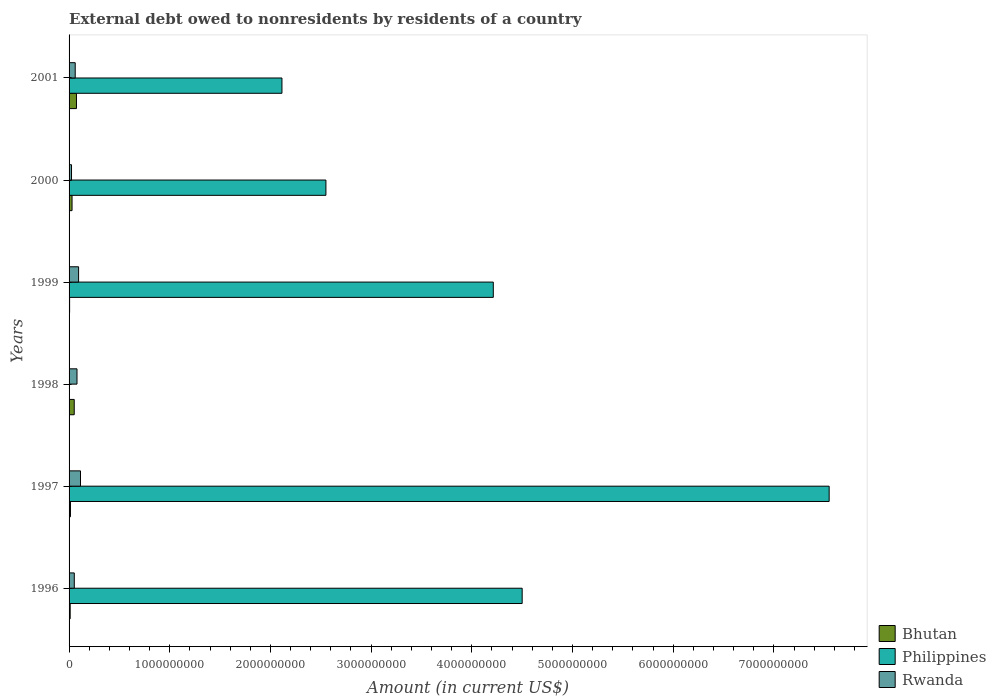How many different coloured bars are there?
Your answer should be very brief. 3. How many groups of bars are there?
Your answer should be very brief. 6. Are the number of bars per tick equal to the number of legend labels?
Your answer should be compact. No. Are the number of bars on each tick of the Y-axis equal?
Offer a very short reply. No. How many bars are there on the 1st tick from the bottom?
Provide a short and direct response. 3. What is the label of the 5th group of bars from the top?
Make the answer very short. 1997. In how many cases, is the number of bars for a given year not equal to the number of legend labels?
Keep it short and to the point. 1. What is the external debt owed by residents in Rwanda in 1999?
Your answer should be compact. 9.46e+07. Across all years, what is the maximum external debt owed by residents in Philippines?
Keep it short and to the point. 7.55e+09. Across all years, what is the minimum external debt owed by residents in Rwanda?
Provide a short and direct response. 2.43e+07. In which year was the external debt owed by residents in Bhutan maximum?
Keep it short and to the point. 2001. What is the total external debt owed by residents in Philippines in the graph?
Provide a succinct answer. 2.09e+1. What is the difference between the external debt owed by residents in Philippines in 1996 and that in 2000?
Provide a succinct answer. 1.95e+09. What is the difference between the external debt owed by residents in Bhutan in 1998 and the external debt owed by residents in Rwanda in 1997?
Your answer should be compact. -6.22e+07. What is the average external debt owed by residents in Rwanda per year?
Provide a succinct answer. 7.07e+07. In the year 2001, what is the difference between the external debt owed by residents in Bhutan and external debt owed by residents in Rwanda?
Give a very brief answer. 1.24e+07. In how many years, is the external debt owed by residents in Bhutan greater than 2200000000 US$?
Offer a terse response. 0. What is the ratio of the external debt owed by residents in Rwanda in 1997 to that in 1999?
Your answer should be very brief. 1.2. What is the difference between the highest and the second highest external debt owed by residents in Philippines?
Make the answer very short. 3.05e+09. What is the difference between the highest and the lowest external debt owed by residents in Rwanda?
Ensure brevity in your answer.  8.92e+07. In how many years, is the external debt owed by residents in Philippines greater than the average external debt owed by residents in Philippines taken over all years?
Keep it short and to the point. 3. Is the sum of the external debt owed by residents in Rwanda in 1997 and 1998 greater than the maximum external debt owed by residents in Philippines across all years?
Offer a terse response. No. Is it the case that in every year, the sum of the external debt owed by residents in Philippines and external debt owed by residents in Rwanda is greater than the external debt owed by residents in Bhutan?
Make the answer very short. Yes. Are all the bars in the graph horizontal?
Your response must be concise. Yes. Are the values on the major ticks of X-axis written in scientific E-notation?
Your answer should be very brief. No. Does the graph contain grids?
Your answer should be compact. No. How many legend labels are there?
Your answer should be compact. 3. How are the legend labels stacked?
Ensure brevity in your answer.  Vertical. What is the title of the graph?
Offer a very short reply. External debt owed to nonresidents by residents of a country. What is the label or title of the X-axis?
Give a very brief answer. Amount (in current US$). What is the Amount (in current US$) in Bhutan in 1996?
Offer a very short reply. 1.10e+07. What is the Amount (in current US$) of Philippines in 1996?
Offer a very short reply. 4.50e+09. What is the Amount (in current US$) in Rwanda in 1996?
Make the answer very short. 5.19e+07. What is the Amount (in current US$) in Bhutan in 1997?
Provide a succinct answer. 1.38e+07. What is the Amount (in current US$) of Philippines in 1997?
Keep it short and to the point. 7.55e+09. What is the Amount (in current US$) in Rwanda in 1997?
Your response must be concise. 1.13e+08. What is the Amount (in current US$) in Bhutan in 1998?
Your answer should be very brief. 5.13e+07. What is the Amount (in current US$) in Philippines in 1998?
Your response must be concise. 0. What is the Amount (in current US$) in Rwanda in 1998?
Provide a succinct answer. 7.87e+07. What is the Amount (in current US$) in Bhutan in 1999?
Make the answer very short. 5.40e+06. What is the Amount (in current US$) of Philippines in 1999?
Offer a terse response. 4.21e+09. What is the Amount (in current US$) in Rwanda in 1999?
Keep it short and to the point. 9.46e+07. What is the Amount (in current US$) in Bhutan in 2000?
Give a very brief answer. 2.96e+07. What is the Amount (in current US$) in Philippines in 2000?
Make the answer very short. 2.55e+09. What is the Amount (in current US$) in Rwanda in 2000?
Keep it short and to the point. 2.43e+07. What is the Amount (in current US$) of Bhutan in 2001?
Your answer should be compact. 7.34e+07. What is the Amount (in current US$) of Philippines in 2001?
Give a very brief answer. 2.11e+09. What is the Amount (in current US$) in Rwanda in 2001?
Make the answer very short. 6.10e+07. Across all years, what is the maximum Amount (in current US$) of Bhutan?
Provide a succinct answer. 7.34e+07. Across all years, what is the maximum Amount (in current US$) of Philippines?
Your response must be concise. 7.55e+09. Across all years, what is the maximum Amount (in current US$) in Rwanda?
Your response must be concise. 1.13e+08. Across all years, what is the minimum Amount (in current US$) of Bhutan?
Ensure brevity in your answer.  5.40e+06. Across all years, what is the minimum Amount (in current US$) in Rwanda?
Make the answer very short. 2.43e+07. What is the total Amount (in current US$) of Bhutan in the graph?
Your answer should be compact. 1.84e+08. What is the total Amount (in current US$) in Philippines in the graph?
Provide a short and direct response. 2.09e+1. What is the total Amount (in current US$) in Rwanda in the graph?
Make the answer very short. 4.24e+08. What is the difference between the Amount (in current US$) in Bhutan in 1996 and that in 1997?
Your answer should be compact. -2.83e+06. What is the difference between the Amount (in current US$) in Philippines in 1996 and that in 1997?
Give a very brief answer. -3.05e+09. What is the difference between the Amount (in current US$) of Rwanda in 1996 and that in 1997?
Keep it short and to the point. -6.16e+07. What is the difference between the Amount (in current US$) of Bhutan in 1996 and that in 1998?
Your answer should be compact. -4.03e+07. What is the difference between the Amount (in current US$) of Rwanda in 1996 and that in 1998?
Ensure brevity in your answer.  -2.68e+07. What is the difference between the Amount (in current US$) of Bhutan in 1996 and that in 1999?
Provide a short and direct response. 5.57e+06. What is the difference between the Amount (in current US$) in Philippines in 1996 and that in 1999?
Your response must be concise. 2.87e+08. What is the difference between the Amount (in current US$) in Rwanda in 1996 and that in 1999?
Offer a terse response. -4.27e+07. What is the difference between the Amount (in current US$) of Bhutan in 1996 and that in 2000?
Your answer should be very brief. -1.86e+07. What is the difference between the Amount (in current US$) in Philippines in 1996 and that in 2000?
Offer a very short reply. 1.95e+09. What is the difference between the Amount (in current US$) in Rwanda in 1996 and that in 2000?
Ensure brevity in your answer.  2.76e+07. What is the difference between the Amount (in current US$) in Bhutan in 1996 and that in 2001?
Your answer should be very brief. -6.24e+07. What is the difference between the Amount (in current US$) in Philippines in 1996 and that in 2001?
Your answer should be very brief. 2.39e+09. What is the difference between the Amount (in current US$) in Rwanda in 1996 and that in 2001?
Ensure brevity in your answer.  -9.10e+06. What is the difference between the Amount (in current US$) in Bhutan in 1997 and that in 1998?
Provide a succinct answer. -3.75e+07. What is the difference between the Amount (in current US$) in Rwanda in 1997 and that in 1998?
Your answer should be very brief. 3.48e+07. What is the difference between the Amount (in current US$) of Bhutan in 1997 and that in 1999?
Keep it short and to the point. 8.40e+06. What is the difference between the Amount (in current US$) in Philippines in 1997 and that in 1999?
Give a very brief answer. 3.34e+09. What is the difference between the Amount (in current US$) in Rwanda in 1997 and that in 1999?
Ensure brevity in your answer.  1.89e+07. What is the difference between the Amount (in current US$) of Bhutan in 1997 and that in 2000?
Give a very brief answer. -1.58e+07. What is the difference between the Amount (in current US$) of Philippines in 1997 and that in 2000?
Your answer should be compact. 5.00e+09. What is the difference between the Amount (in current US$) of Rwanda in 1997 and that in 2000?
Your answer should be compact. 8.92e+07. What is the difference between the Amount (in current US$) in Bhutan in 1997 and that in 2001?
Your response must be concise. -5.96e+07. What is the difference between the Amount (in current US$) of Philippines in 1997 and that in 2001?
Provide a succinct answer. 5.43e+09. What is the difference between the Amount (in current US$) in Rwanda in 1997 and that in 2001?
Give a very brief answer. 5.25e+07. What is the difference between the Amount (in current US$) in Bhutan in 1998 and that in 1999?
Offer a terse response. 4.59e+07. What is the difference between the Amount (in current US$) in Rwanda in 1998 and that in 1999?
Your response must be concise. -1.59e+07. What is the difference between the Amount (in current US$) of Bhutan in 1998 and that in 2000?
Provide a succinct answer. 2.16e+07. What is the difference between the Amount (in current US$) of Rwanda in 1998 and that in 2000?
Keep it short and to the point. 5.44e+07. What is the difference between the Amount (in current US$) of Bhutan in 1998 and that in 2001?
Provide a succinct answer. -2.22e+07. What is the difference between the Amount (in current US$) in Rwanda in 1998 and that in 2001?
Offer a terse response. 1.77e+07. What is the difference between the Amount (in current US$) in Bhutan in 1999 and that in 2000?
Offer a terse response. -2.42e+07. What is the difference between the Amount (in current US$) in Philippines in 1999 and that in 2000?
Make the answer very short. 1.66e+09. What is the difference between the Amount (in current US$) in Rwanda in 1999 and that in 2000?
Your answer should be compact. 7.03e+07. What is the difference between the Amount (in current US$) of Bhutan in 1999 and that in 2001?
Your answer should be very brief. -6.80e+07. What is the difference between the Amount (in current US$) of Philippines in 1999 and that in 2001?
Offer a very short reply. 2.10e+09. What is the difference between the Amount (in current US$) in Rwanda in 1999 and that in 2001?
Provide a succinct answer. 3.36e+07. What is the difference between the Amount (in current US$) of Bhutan in 2000 and that in 2001?
Provide a succinct answer. -4.38e+07. What is the difference between the Amount (in current US$) in Philippines in 2000 and that in 2001?
Provide a short and direct response. 4.37e+08. What is the difference between the Amount (in current US$) of Rwanda in 2000 and that in 2001?
Offer a terse response. -3.67e+07. What is the difference between the Amount (in current US$) of Bhutan in 1996 and the Amount (in current US$) of Philippines in 1997?
Provide a succinct answer. -7.54e+09. What is the difference between the Amount (in current US$) of Bhutan in 1996 and the Amount (in current US$) of Rwanda in 1997?
Keep it short and to the point. -1.03e+08. What is the difference between the Amount (in current US$) in Philippines in 1996 and the Amount (in current US$) in Rwanda in 1997?
Give a very brief answer. 4.39e+09. What is the difference between the Amount (in current US$) in Bhutan in 1996 and the Amount (in current US$) in Rwanda in 1998?
Provide a succinct answer. -6.77e+07. What is the difference between the Amount (in current US$) in Philippines in 1996 and the Amount (in current US$) in Rwanda in 1998?
Ensure brevity in your answer.  4.42e+09. What is the difference between the Amount (in current US$) in Bhutan in 1996 and the Amount (in current US$) in Philippines in 1999?
Provide a short and direct response. -4.20e+09. What is the difference between the Amount (in current US$) of Bhutan in 1996 and the Amount (in current US$) of Rwanda in 1999?
Your answer should be compact. -8.36e+07. What is the difference between the Amount (in current US$) of Philippines in 1996 and the Amount (in current US$) of Rwanda in 1999?
Give a very brief answer. 4.41e+09. What is the difference between the Amount (in current US$) in Bhutan in 1996 and the Amount (in current US$) in Philippines in 2000?
Make the answer very short. -2.54e+09. What is the difference between the Amount (in current US$) in Bhutan in 1996 and the Amount (in current US$) in Rwanda in 2000?
Offer a terse response. -1.33e+07. What is the difference between the Amount (in current US$) in Philippines in 1996 and the Amount (in current US$) in Rwanda in 2000?
Give a very brief answer. 4.48e+09. What is the difference between the Amount (in current US$) in Bhutan in 1996 and the Amount (in current US$) in Philippines in 2001?
Ensure brevity in your answer.  -2.10e+09. What is the difference between the Amount (in current US$) in Bhutan in 1996 and the Amount (in current US$) in Rwanda in 2001?
Provide a short and direct response. -5.00e+07. What is the difference between the Amount (in current US$) in Philippines in 1996 and the Amount (in current US$) in Rwanda in 2001?
Ensure brevity in your answer.  4.44e+09. What is the difference between the Amount (in current US$) of Bhutan in 1997 and the Amount (in current US$) of Rwanda in 1998?
Offer a very short reply. -6.49e+07. What is the difference between the Amount (in current US$) in Philippines in 1997 and the Amount (in current US$) in Rwanda in 1998?
Provide a succinct answer. 7.47e+09. What is the difference between the Amount (in current US$) in Bhutan in 1997 and the Amount (in current US$) in Philippines in 1999?
Provide a short and direct response. -4.20e+09. What is the difference between the Amount (in current US$) in Bhutan in 1997 and the Amount (in current US$) in Rwanda in 1999?
Your answer should be compact. -8.08e+07. What is the difference between the Amount (in current US$) of Philippines in 1997 and the Amount (in current US$) of Rwanda in 1999?
Keep it short and to the point. 7.45e+09. What is the difference between the Amount (in current US$) of Bhutan in 1997 and the Amount (in current US$) of Philippines in 2000?
Your response must be concise. -2.54e+09. What is the difference between the Amount (in current US$) in Bhutan in 1997 and the Amount (in current US$) in Rwanda in 2000?
Your answer should be very brief. -1.05e+07. What is the difference between the Amount (in current US$) in Philippines in 1997 and the Amount (in current US$) in Rwanda in 2000?
Your answer should be compact. 7.52e+09. What is the difference between the Amount (in current US$) in Bhutan in 1997 and the Amount (in current US$) in Philippines in 2001?
Give a very brief answer. -2.10e+09. What is the difference between the Amount (in current US$) in Bhutan in 1997 and the Amount (in current US$) in Rwanda in 2001?
Keep it short and to the point. -4.72e+07. What is the difference between the Amount (in current US$) of Philippines in 1997 and the Amount (in current US$) of Rwanda in 2001?
Make the answer very short. 7.49e+09. What is the difference between the Amount (in current US$) of Bhutan in 1998 and the Amount (in current US$) of Philippines in 1999?
Make the answer very short. -4.16e+09. What is the difference between the Amount (in current US$) in Bhutan in 1998 and the Amount (in current US$) in Rwanda in 1999?
Ensure brevity in your answer.  -4.33e+07. What is the difference between the Amount (in current US$) of Bhutan in 1998 and the Amount (in current US$) of Philippines in 2000?
Your answer should be very brief. -2.50e+09. What is the difference between the Amount (in current US$) in Bhutan in 1998 and the Amount (in current US$) in Rwanda in 2000?
Offer a very short reply. 2.70e+07. What is the difference between the Amount (in current US$) in Bhutan in 1998 and the Amount (in current US$) in Philippines in 2001?
Keep it short and to the point. -2.06e+09. What is the difference between the Amount (in current US$) of Bhutan in 1998 and the Amount (in current US$) of Rwanda in 2001?
Provide a short and direct response. -9.76e+06. What is the difference between the Amount (in current US$) of Bhutan in 1999 and the Amount (in current US$) of Philippines in 2000?
Your answer should be very brief. -2.55e+09. What is the difference between the Amount (in current US$) of Bhutan in 1999 and the Amount (in current US$) of Rwanda in 2000?
Your answer should be compact. -1.89e+07. What is the difference between the Amount (in current US$) of Philippines in 1999 and the Amount (in current US$) of Rwanda in 2000?
Offer a very short reply. 4.19e+09. What is the difference between the Amount (in current US$) in Bhutan in 1999 and the Amount (in current US$) in Philippines in 2001?
Provide a short and direct response. -2.11e+09. What is the difference between the Amount (in current US$) of Bhutan in 1999 and the Amount (in current US$) of Rwanda in 2001?
Offer a terse response. -5.56e+07. What is the difference between the Amount (in current US$) of Philippines in 1999 and the Amount (in current US$) of Rwanda in 2001?
Your answer should be very brief. 4.15e+09. What is the difference between the Amount (in current US$) of Bhutan in 2000 and the Amount (in current US$) of Philippines in 2001?
Provide a short and direct response. -2.08e+09. What is the difference between the Amount (in current US$) in Bhutan in 2000 and the Amount (in current US$) in Rwanda in 2001?
Your response must be concise. -3.14e+07. What is the difference between the Amount (in current US$) in Philippines in 2000 and the Amount (in current US$) in Rwanda in 2001?
Your answer should be compact. 2.49e+09. What is the average Amount (in current US$) of Bhutan per year?
Give a very brief answer. 3.07e+07. What is the average Amount (in current US$) in Philippines per year?
Your answer should be very brief. 3.49e+09. What is the average Amount (in current US$) of Rwanda per year?
Keep it short and to the point. 7.07e+07. In the year 1996, what is the difference between the Amount (in current US$) of Bhutan and Amount (in current US$) of Philippines?
Provide a succinct answer. -4.49e+09. In the year 1996, what is the difference between the Amount (in current US$) in Bhutan and Amount (in current US$) in Rwanda?
Offer a terse response. -4.09e+07. In the year 1996, what is the difference between the Amount (in current US$) of Philippines and Amount (in current US$) of Rwanda?
Ensure brevity in your answer.  4.45e+09. In the year 1997, what is the difference between the Amount (in current US$) in Bhutan and Amount (in current US$) in Philippines?
Offer a terse response. -7.54e+09. In the year 1997, what is the difference between the Amount (in current US$) of Bhutan and Amount (in current US$) of Rwanda?
Your answer should be compact. -9.97e+07. In the year 1997, what is the difference between the Amount (in current US$) of Philippines and Amount (in current US$) of Rwanda?
Offer a very short reply. 7.44e+09. In the year 1998, what is the difference between the Amount (in current US$) of Bhutan and Amount (in current US$) of Rwanda?
Ensure brevity in your answer.  -2.74e+07. In the year 1999, what is the difference between the Amount (in current US$) in Bhutan and Amount (in current US$) in Philippines?
Provide a short and direct response. -4.21e+09. In the year 1999, what is the difference between the Amount (in current US$) of Bhutan and Amount (in current US$) of Rwanda?
Your answer should be compact. -8.92e+07. In the year 1999, what is the difference between the Amount (in current US$) in Philippines and Amount (in current US$) in Rwanda?
Keep it short and to the point. 4.12e+09. In the year 2000, what is the difference between the Amount (in current US$) of Bhutan and Amount (in current US$) of Philippines?
Your response must be concise. -2.52e+09. In the year 2000, what is the difference between the Amount (in current US$) in Bhutan and Amount (in current US$) in Rwanda?
Your answer should be very brief. 5.32e+06. In the year 2000, what is the difference between the Amount (in current US$) in Philippines and Amount (in current US$) in Rwanda?
Your answer should be compact. 2.53e+09. In the year 2001, what is the difference between the Amount (in current US$) in Bhutan and Amount (in current US$) in Philippines?
Provide a short and direct response. -2.04e+09. In the year 2001, what is the difference between the Amount (in current US$) of Bhutan and Amount (in current US$) of Rwanda?
Give a very brief answer. 1.24e+07. In the year 2001, what is the difference between the Amount (in current US$) in Philippines and Amount (in current US$) in Rwanda?
Make the answer very short. 2.05e+09. What is the ratio of the Amount (in current US$) of Bhutan in 1996 to that in 1997?
Give a very brief answer. 0.8. What is the ratio of the Amount (in current US$) in Philippines in 1996 to that in 1997?
Ensure brevity in your answer.  0.6. What is the ratio of the Amount (in current US$) in Rwanda in 1996 to that in 1997?
Provide a succinct answer. 0.46. What is the ratio of the Amount (in current US$) of Bhutan in 1996 to that in 1998?
Keep it short and to the point. 0.21. What is the ratio of the Amount (in current US$) in Rwanda in 1996 to that in 1998?
Ensure brevity in your answer.  0.66. What is the ratio of the Amount (in current US$) of Bhutan in 1996 to that in 1999?
Your answer should be compact. 2.03. What is the ratio of the Amount (in current US$) of Philippines in 1996 to that in 1999?
Your response must be concise. 1.07. What is the ratio of the Amount (in current US$) in Rwanda in 1996 to that in 1999?
Keep it short and to the point. 0.55. What is the ratio of the Amount (in current US$) of Bhutan in 1996 to that in 2000?
Ensure brevity in your answer.  0.37. What is the ratio of the Amount (in current US$) of Philippines in 1996 to that in 2000?
Offer a terse response. 1.76. What is the ratio of the Amount (in current US$) of Rwanda in 1996 to that in 2000?
Make the answer very short. 2.14. What is the ratio of the Amount (in current US$) of Bhutan in 1996 to that in 2001?
Provide a short and direct response. 0.15. What is the ratio of the Amount (in current US$) in Philippines in 1996 to that in 2001?
Your answer should be very brief. 2.13. What is the ratio of the Amount (in current US$) in Rwanda in 1996 to that in 2001?
Keep it short and to the point. 0.85. What is the ratio of the Amount (in current US$) of Bhutan in 1997 to that in 1998?
Provide a short and direct response. 0.27. What is the ratio of the Amount (in current US$) of Rwanda in 1997 to that in 1998?
Ensure brevity in your answer.  1.44. What is the ratio of the Amount (in current US$) of Bhutan in 1997 to that in 1999?
Keep it short and to the point. 2.56. What is the ratio of the Amount (in current US$) in Philippines in 1997 to that in 1999?
Keep it short and to the point. 1.79. What is the ratio of the Amount (in current US$) in Rwanda in 1997 to that in 1999?
Your response must be concise. 1.2. What is the ratio of the Amount (in current US$) in Bhutan in 1997 to that in 2000?
Make the answer very short. 0.47. What is the ratio of the Amount (in current US$) of Philippines in 1997 to that in 2000?
Ensure brevity in your answer.  2.96. What is the ratio of the Amount (in current US$) of Rwanda in 1997 to that in 2000?
Ensure brevity in your answer.  4.67. What is the ratio of the Amount (in current US$) of Bhutan in 1997 to that in 2001?
Provide a short and direct response. 0.19. What is the ratio of the Amount (in current US$) of Philippines in 1997 to that in 2001?
Your answer should be very brief. 3.57. What is the ratio of the Amount (in current US$) in Rwanda in 1997 to that in 2001?
Offer a very short reply. 1.86. What is the ratio of the Amount (in current US$) in Bhutan in 1998 to that in 1999?
Your answer should be compact. 9.5. What is the ratio of the Amount (in current US$) in Rwanda in 1998 to that in 1999?
Your answer should be very brief. 0.83. What is the ratio of the Amount (in current US$) in Bhutan in 1998 to that in 2000?
Your answer should be very brief. 1.73. What is the ratio of the Amount (in current US$) of Rwanda in 1998 to that in 2000?
Provide a short and direct response. 3.24. What is the ratio of the Amount (in current US$) in Bhutan in 1998 to that in 2001?
Provide a succinct answer. 0.7. What is the ratio of the Amount (in current US$) in Rwanda in 1998 to that in 2001?
Your answer should be very brief. 1.29. What is the ratio of the Amount (in current US$) in Bhutan in 1999 to that in 2000?
Ensure brevity in your answer.  0.18. What is the ratio of the Amount (in current US$) in Philippines in 1999 to that in 2000?
Your response must be concise. 1.65. What is the ratio of the Amount (in current US$) of Rwanda in 1999 to that in 2000?
Provide a succinct answer. 3.89. What is the ratio of the Amount (in current US$) in Bhutan in 1999 to that in 2001?
Offer a very short reply. 0.07. What is the ratio of the Amount (in current US$) of Philippines in 1999 to that in 2001?
Provide a succinct answer. 1.99. What is the ratio of the Amount (in current US$) in Rwanda in 1999 to that in 2001?
Make the answer very short. 1.55. What is the ratio of the Amount (in current US$) of Bhutan in 2000 to that in 2001?
Provide a succinct answer. 0.4. What is the ratio of the Amount (in current US$) of Philippines in 2000 to that in 2001?
Offer a terse response. 1.21. What is the ratio of the Amount (in current US$) in Rwanda in 2000 to that in 2001?
Provide a succinct answer. 0.4. What is the difference between the highest and the second highest Amount (in current US$) of Bhutan?
Offer a very short reply. 2.22e+07. What is the difference between the highest and the second highest Amount (in current US$) in Philippines?
Your response must be concise. 3.05e+09. What is the difference between the highest and the second highest Amount (in current US$) of Rwanda?
Keep it short and to the point. 1.89e+07. What is the difference between the highest and the lowest Amount (in current US$) of Bhutan?
Make the answer very short. 6.80e+07. What is the difference between the highest and the lowest Amount (in current US$) in Philippines?
Ensure brevity in your answer.  7.55e+09. What is the difference between the highest and the lowest Amount (in current US$) in Rwanda?
Make the answer very short. 8.92e+07. 